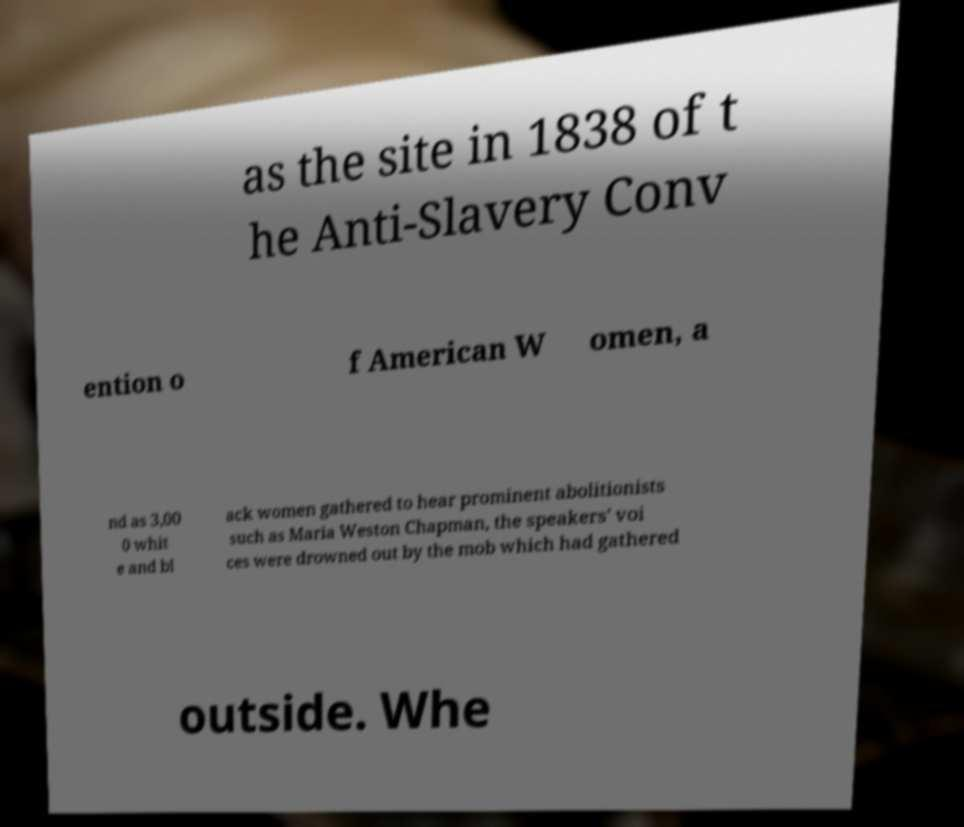Please read and relay the text visible in this image. What does it say? as the site in 1838 of t he Anti-Slavery Conv ention o f American W omen, a nd as 3,00 0 whit e and bl ack women gathered to hear prominent abolitionists such as Maria Weston Chapman, the speakers' voi ces were drowned out by the mob which had gathered outside. Whe 